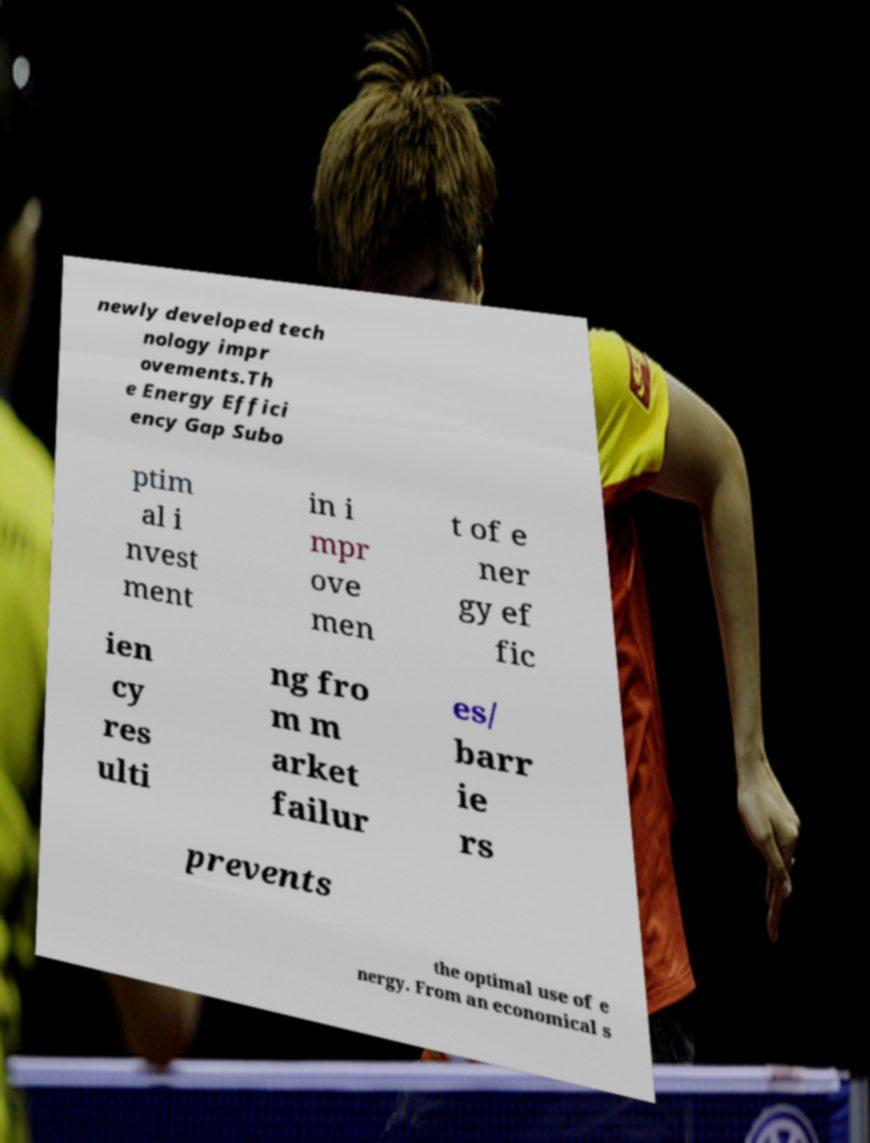Could you extract and type out the text from this image? newly developed tech nology impr ovements.Th e Energy Effici ency Gap Subo ptim al i nvest ment in i mpr ove men t of e ner gy ef fic ien cy res ulti ng fro m m arket failur es/ barr ie rs prevents the optimal use of e nergy. From an economical s 